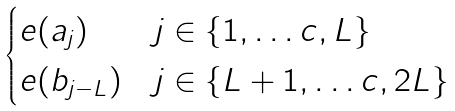<formula> <loc_0><loc_0><loc_500><loc_500>\begin{cases} e ( a _ { j } ) & j \in \{ 1 , \dots c , L \} \\ e ( b _ { j - L } ) & j \in \{ L + 1 , \dots c , 2 L \} \end{cases}</formula> 